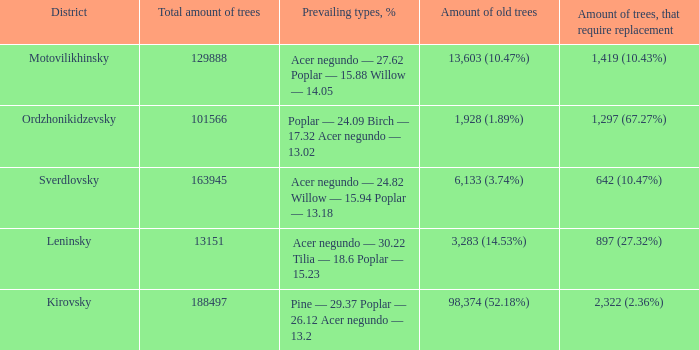What is the district when prevailing types, % is acer negundo — 30.22 tilia — 18.6 poplar — 15.23? Leninsky. 